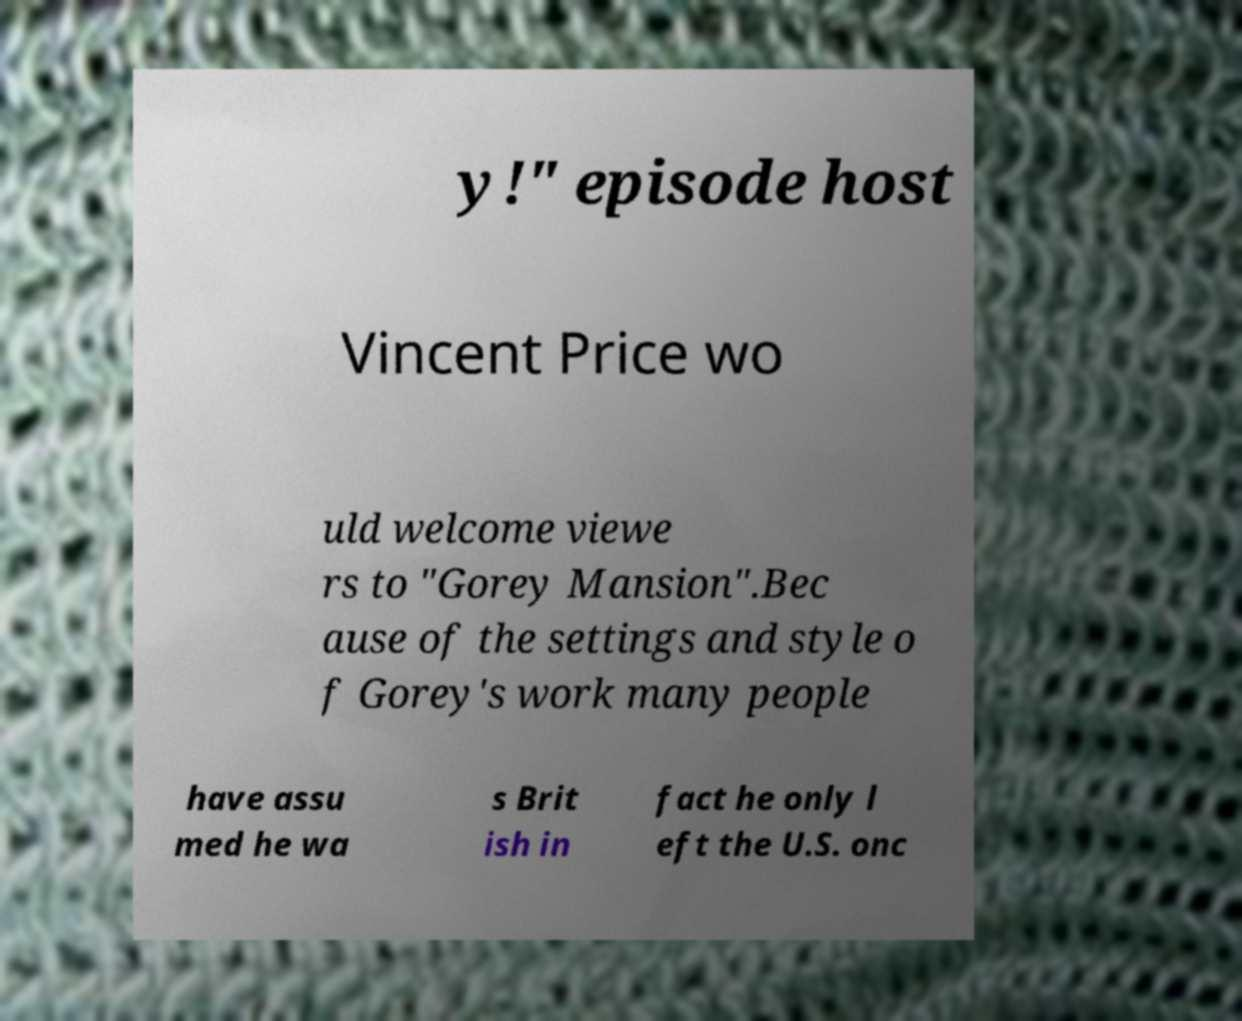There's text embedded in this image that I need extracted. Can you transcribe it verbatim? y!" episode host Vincent Price wo uld welcome viewe rs to "Gorey Mansion".Bec ause of the settings and style o f Gorey's work many people have assu med he wa s Brit ish in fact he only l eft the U.S. onc 